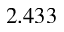Convert formula to latex. <formula><loc_0><loc_0><loc_500><loc_500>2 . 4 3 3</formula> 